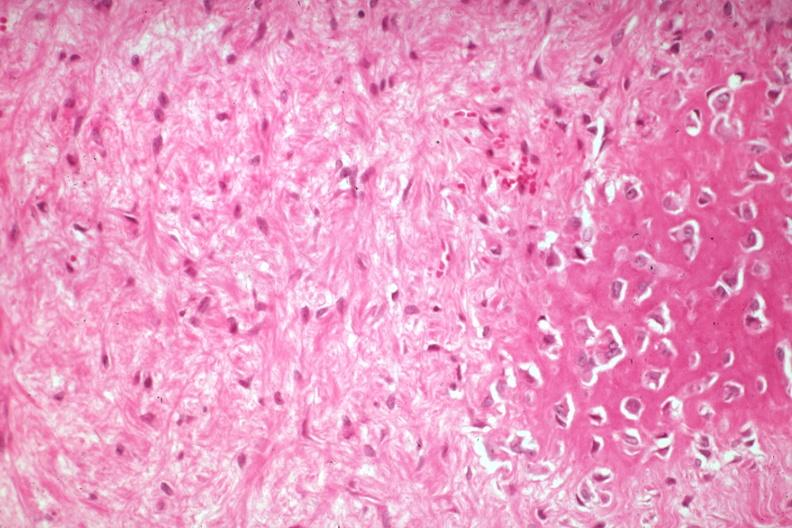what does this image show?
Answer the question using a single word or phrase. High excessive fibrous callus with focal osteoid deposition and osteoblasts 